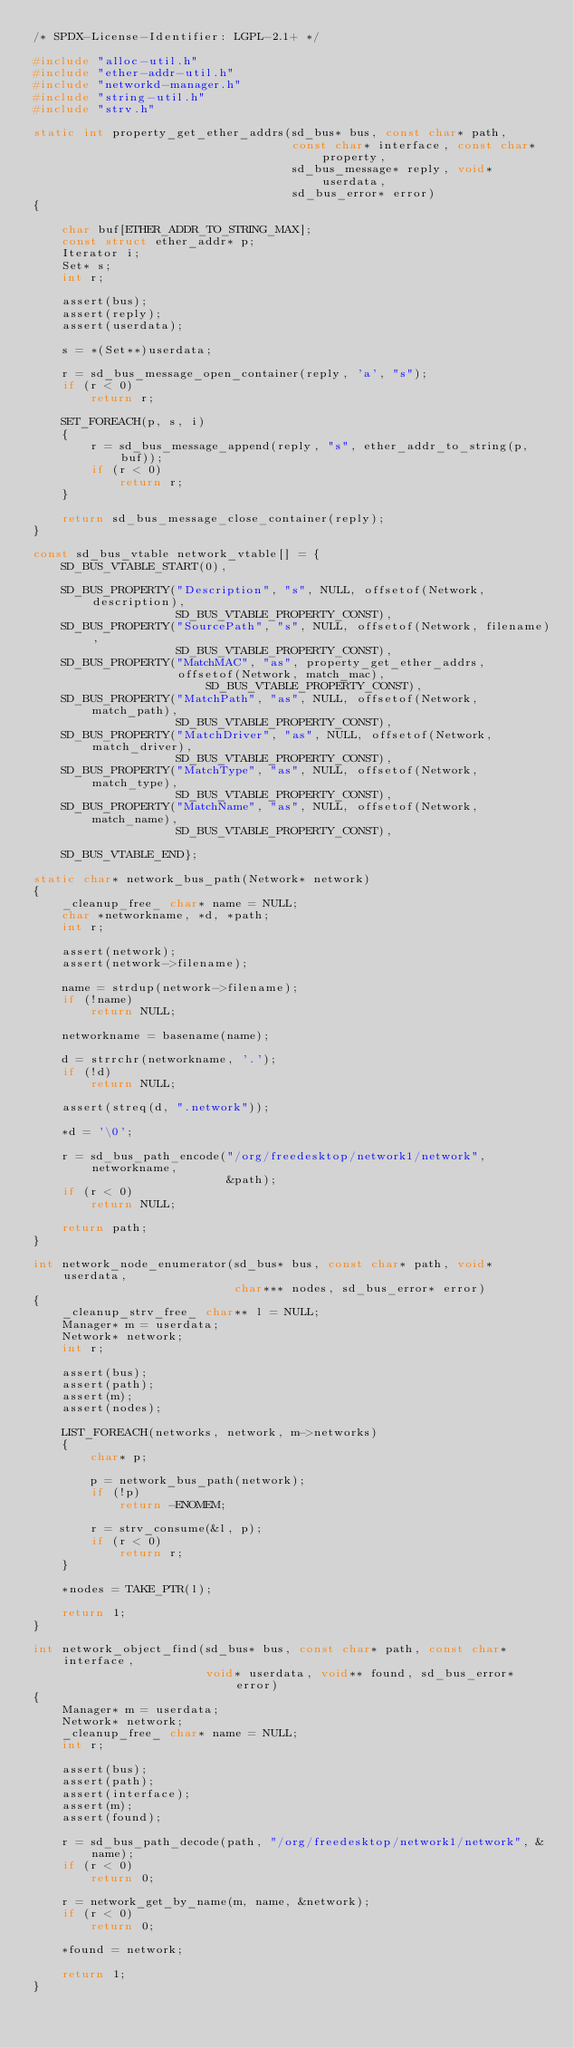Convert code to text. <code><loc_0><loc_0><loc_500><loc_500><_C_>/* SPDX-License-Identifier: LGPL-2.1+ */

#include "alloc-util.h"
#include "ether-addr-util.h"
#include "networkd-manager.h"
#include "string-util.h"
#include "strv.h"

static int property_get_ether_addrs(sd_bus* bus, const char* path,
                                    const char* interface, const char* property,
                                    sd_bus_message* reply, void* userdata,
                                    sd_bus_error* error)
{

    char buf[ETHER_ADDR_TO_STRING_MAX];
    const struct ether_addr* p;
    Iterator i;
    Set* s;
    int r;

    assert(bus);
    assert(reply);
    assert(userdata);

    s = *(Set**)userdata;

    r = sd_bus_message_open_container(reply, 'a', "s");
    if (r < 0)
        return r;

    SET_FOREACH(p, s, i)
    {
        r = sd_bus_message_append(reply, "s", ether_addr_to_string(p, buf));
        if (r < 0)
            return r;
    }

    return sd_bus_message_close_container(reply);
}

const sd_bus_vtable network_vtable[] = {
    SD_BUS_VTABLE_START(0),

    SD_BUS_PROPERTY("Description", "s", NULL, offsetof(Network, description),
                    SD_BUS_VTABLE_PROPERTY_CONST),
    SD_BUS_PROPERTY("SourcePath", "s", NULL, offsetof(Network, filename),
                    SD_BUS_VTABLE_PROPERTY_CONST),
    SD_BUS_PROPERTY("MatchMAC", "as", property_get_ether_addrs,
                    offsetof(Network, match_mac), SD_BUS_VTABLE_PROPERTY_CONST),
    SD_BUS_PROPERTY("MatchPath", "as", NULL, offsetof(Network, match_path),
                    SD_BUS_VTABLE_PROPERTY_CONST),
    SD_BUS_PROPERTY("MatchDriver", "as", NULL, offsetof(Network, match_driver),
                    SD_BUS_VTABLE_PROPERTY_CONST),
    SD_BUS_PROPERTY("MatchType", "as", NULL, offsetof(Network, match_type),
                    SD_BUS_VTABLE_PROPERTY_CONST),
    SD_BUS_PROPERTY("MatchName", "as", NULL, offsetof(Network, match_name),
                    SD_BUS_VTABLE_PROPERTY_CONST),

    SD_BUS_VTABLE_END};

static char* network_bus_path(Network* network)
{
    _cleanup_free_ char* name = NULL;
    char *networkname, *d, *path;
    int r;

    assert(network);
    assert(network->filename);

    name = strdup(network->filename);
    if (!name)
        return NULL;

    networkname = basename(name);

    d = strrchr(networkname, '.');
    if (!d)
        return NULL;

    assert(streq(d, ".network"));

    *d = '\0';

    r = sd_bus_path_encode("/org/freedesktop/network1/network", networkname,
                           &path);
    if (r < 0)
        return NULL;

    return path;
}

int network_node_enumerator(sd_bus* bus, const char* path, void* userdata,
                            char*** nodes, sd_bus_error* error)
{
    _cleanup_strv_free_ char** l = NULL;
    Manager* m = userdata;
    Network* network;
    int r;

    assert(bus);
    assert(path);
    assert(m);
    assert(nodes);

    LIST_FOREACH(networks, network, m->networks)
    {
        char* p;

        p = network_bus_path(network);
        if (!p)
            return -ENOMEM;

        r = strv_consume(&l, p);
        if (r < 0)
            return r;
    }

    *nodes = TAKE_PTR(l);

    return 1;
}

int network_object_find(sd_bus* bus, const char* path, const char* interface,
                        void* userdata, void** found, sd_bus_error* error)
{
    Manager* m = userdata;
    Network* network;
    _cleanup_free_ char* name = NULL;
    int r;

    assert(bus);
    assert(path);
    assert(interface);
    assert(m);
    assert(found);

    r = sd_bus_path_decode(path, "/org/freedesktop/network1/network", &name);
    if (r < 0)
        return 0;

    r = network_get_by_name(m, name, &network);
    if (r < 0)
        return 0;

    *found = network;

    return 1;
}
</code> 